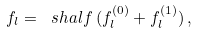Convert formula to latex. <formula><loc_0><loc_0><loc_500><loc_500>f _ { l } = \ s h a l f \, ( f _ { l } ^ { ( 0 ) } + f _ { l } ^ { ( 1 ) } ) \, ,</formula> 